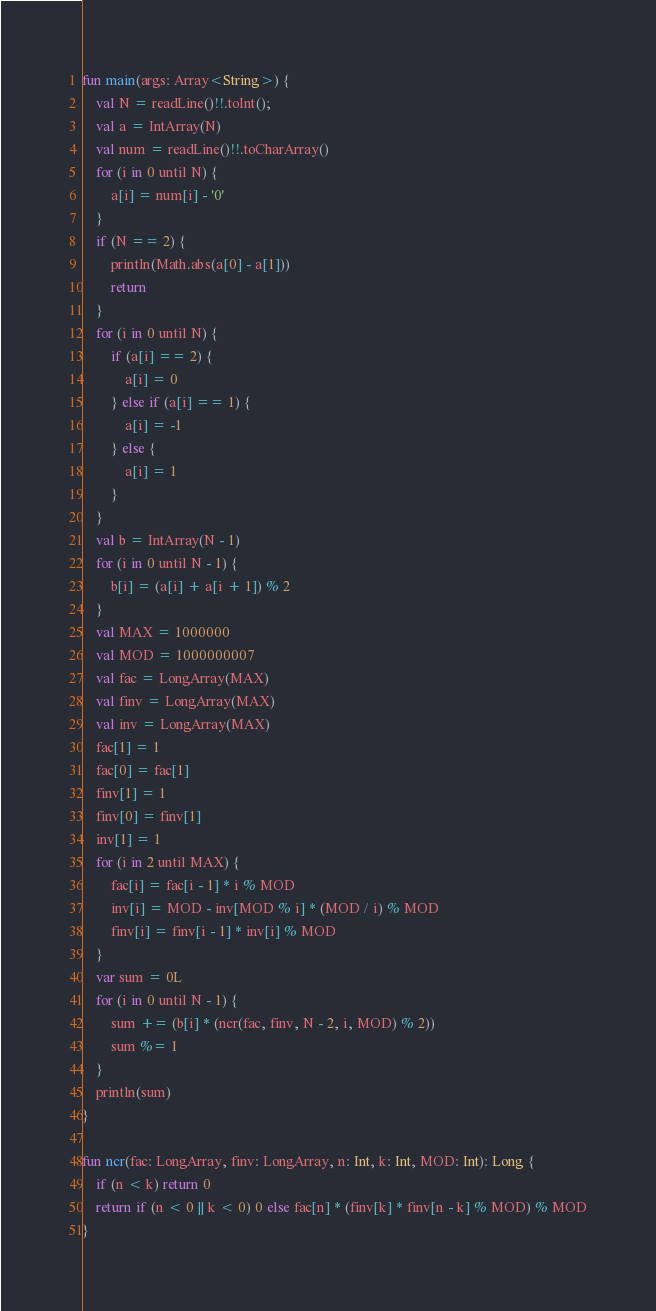<code> <loc_0><loc_0><loc_500><loc_500><_Kotlin_>fun main(args: Array<String>) {
    val N = readLine()!!.toInt();
    val a = IntArray(N)
    val num = readLine()!!.toCharArray()
    for (i in 0 until N) {
        a[i] = num[i] - '0'
    }
    if (N == 2) {
        println(Math.abs(a[0] - a[1]))
        return
    }
    for (i in 0 until N) {
        if (a[i] == 2) {
            a[i] = 0
        } else if (a[i] == 1) {
            a[i] = -1
        } else {
            a[i] = 1
        }
    }
    val b = IntArray(N - 1)
    for (i in 0 until N - 1) {
        b[i] = (a[i] + a[i + 1]) % 2
    }
    val MAX = 1000000
    val MOD = 1000000007
    val fac = LongArray(MAX)
    val finv = LongArray(MAX)
    val inv = LongArray(MAX)
    fac[1] = 1
    fac[0] = fac[1]
    finv[1] = 1
    finv[0] = finv[1]
    inv[1] = 1
    for (i in 2 until MAX) {
        fac[i] = fac[i - 1] * i % MOD
        inv[i] = MOD - inv[MOD % i] * (MOD / i) % MOD
        finv[i] = finv[i - 1] * inv[i] % MOD
    }
    var sum = 0L
    for (i in 0 until N - 1) {
        sum += (b[i] * (ncr(fac, finv, N - 2, i, MOD) % 2))
        sum %= 1
    }
    println(sum)
}

fun ncr(fac: LongArray, finv: LongArray, n: Int, k: Int, MOD: Int): Long {
    if (n < k) return 0
    return if (n < 0 || k < 0) 0 else fac[n] * (finv[k] * finv[n - k] % MOD) % MOD
}
</code> 